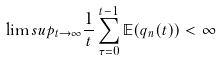<formula> <loc_0><loc_0><loc_500><loc_500>\lim s u p _ { t \rightarrow \infty } \frac { 1 } { t } \sum _ { \tau = 0 } ^ { t - 1 } \mathbb { E } ( q _ { n } ( t ) ) < \infty</formula> 